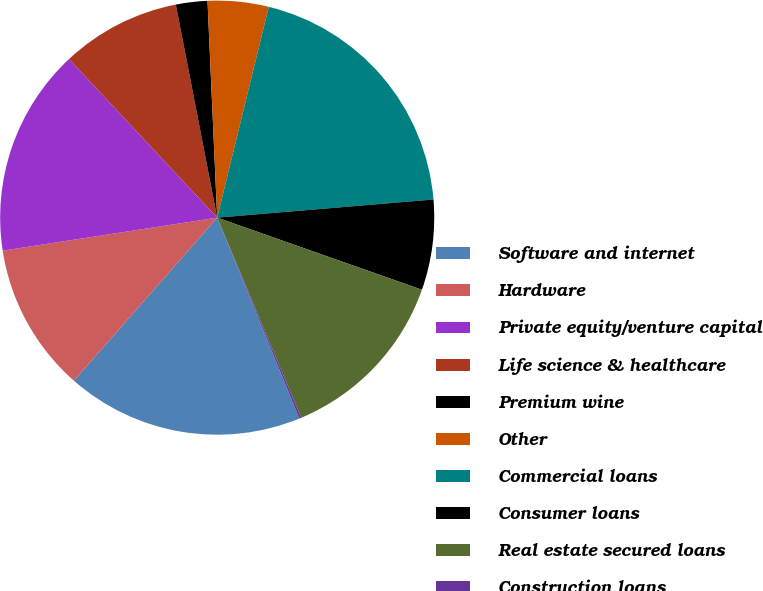Convert chart to OTSL. <chart><loc_0><loc_0><loc_500><loc_500><pie_chart><fcel>Software and internet<fcel>Hardware<fcel>Private equity/venture capital<fcel>Life science & healthcare<fcel>Premium wine<fcel>Other<fcel>Commercial loans<fcel>Consumer loans<fcel>Real estate secured loans<fcel>Construction loans<nl><fcel>17.66%<fcel>11.09%<fcel>15.47%<fcel>8.91%<fcel>2.34%<fcel>4.53%<fcel>19.85%<fcel>6.72%<fcel>13.28%<fcel>0.15%<nl></chart> 